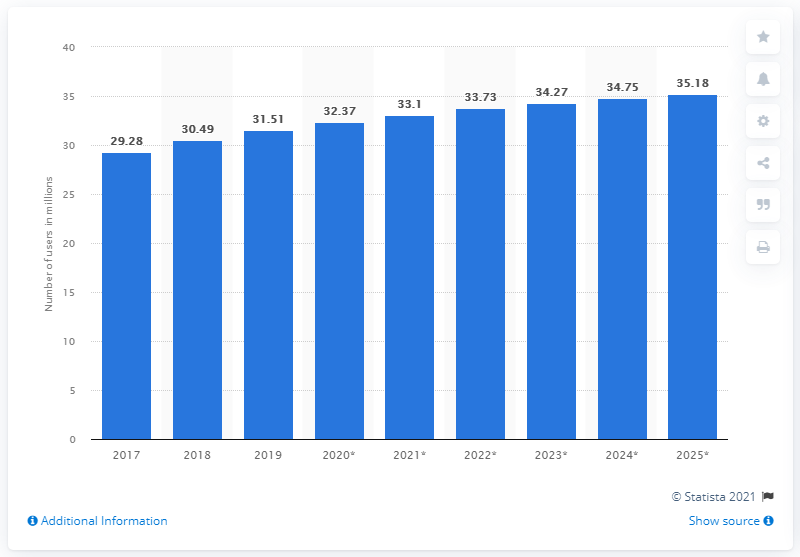Specify some key components in this picture. By 2025, it is expected that a significant number of people in Argentina will be using Facebook. Specifically, it is projected that 35.18% of the population will be active users of the social media platform. 